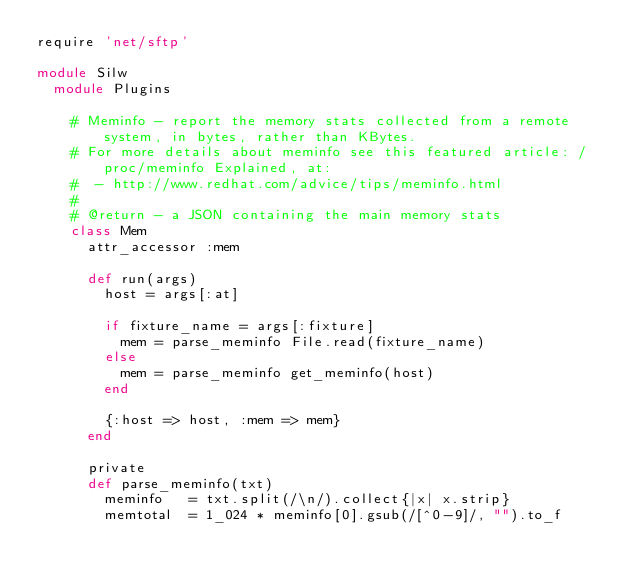<code> <loc_0><loc_0><loc_500><loc_500><_Ruby_>require 'net/sftp'

module Silw
  module Plugins

    # Meminfo - report the memory stats collected from a remote system, in bytes, rather than KBytes.
    # For more details about meminfo see this featured article: /proc/meminfo Explained, at:
    #  - http://www.redhat.com/advice/tips/meminfo.html
    #
    # @return - a JSON containing the main memory stats
    class Mem
      attr_accessor :mem

      def run(args)        
        host = args[:at]

        if fixture_name = args[:fixture]
          mem = parse_meminfo File.read(fixture_name)
        else
          mem = parse_meminfo get_meminfo(host)
        end

        {:host => host, :mem => mem}
      end
      
      private
      def parse_meminfo(txt)
        meminfo   = txt.split(/\n/).collect{|x| x.strip}
        memtotal  = 1_024 * meminfo[0].gsub(/[^0-9]/, "").to_f</code> 